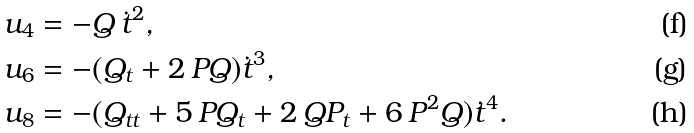Convert formula to latex. <formula><loc_0><loc_0><loc_500><loc_500>u _ { 4 } & = - Q \, \dot { t } ^ { 2 } , \\ u _ { 6 } & = - ( Q _ { t } + 2 \, P Q ) \dot { t } ^ { 3 } , \\ u _ { 8 } & = - ( Q _ { t t } + 5 \, P Q _ { t } + 2 \, Q P _ { t } + 6 \, P ^ { 2 } Q ) \dot { t } ^ { 4 } .</formula> 